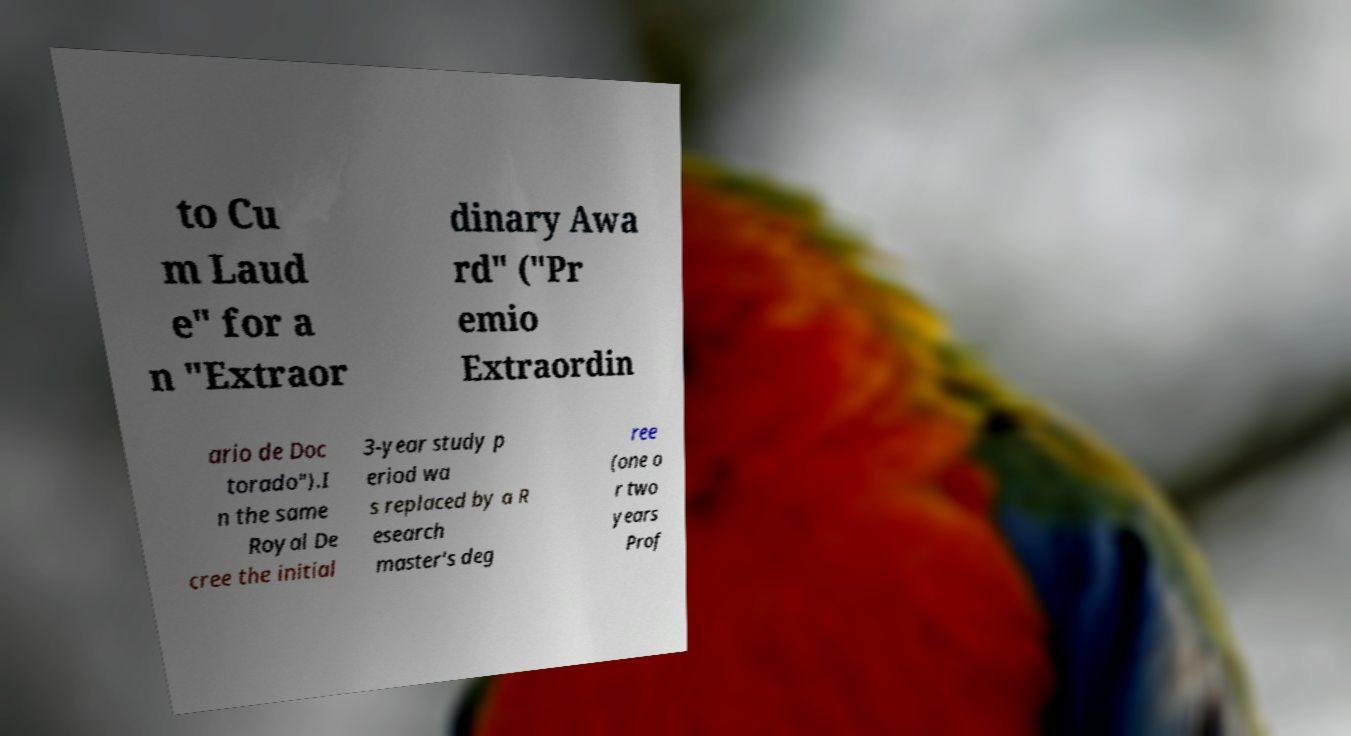Please identify and transcribe the text found in this image. to Cu m Laud e" for a n "Extraor dinary Awa rd" ("Pr emio Extraordin ario de Doc torado").I n the same Royal De cree the initial 3-year study p eriod wa s replaced by a R esearch master's deg ree (one o r two years Prof 